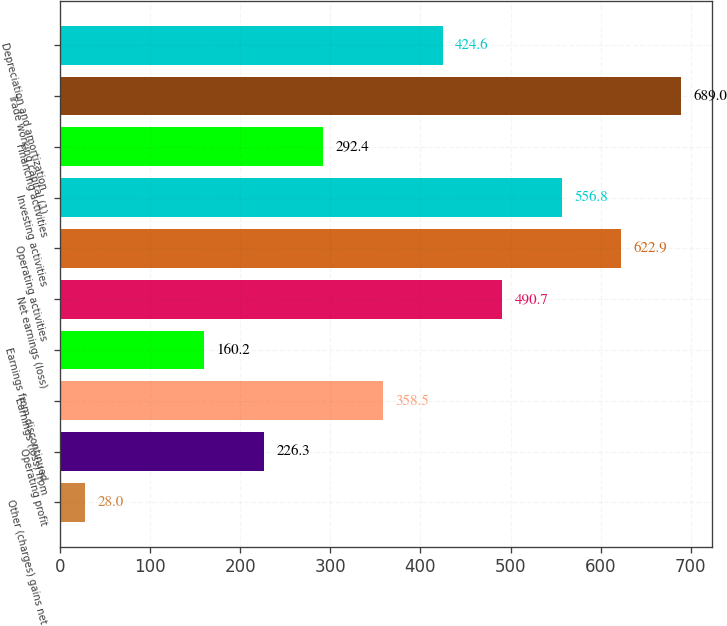Convert chart. <chart><loc_0><loc_0><loc_500><loc_500><bar_chart><fcel>Other (charges) gains net<fcel>Operating profit<fcel>Earnings (loss) from<fcel>Earnings from discontinued<fcel>Net earnings (loss)<fcel>Operating activities<fcel>Investing activities<fcel>Financing activities<fcel>Trade working capital (1)<fcel>Depreciation and amortization<nl><fcel>28<fcel>226.3<fcel>358.5<fcel>160.2<fcel>490.7<fcel>622.9<fcel>556.8<fcel>292.4<fcel>689<fcel>424.6<nl></chart> 